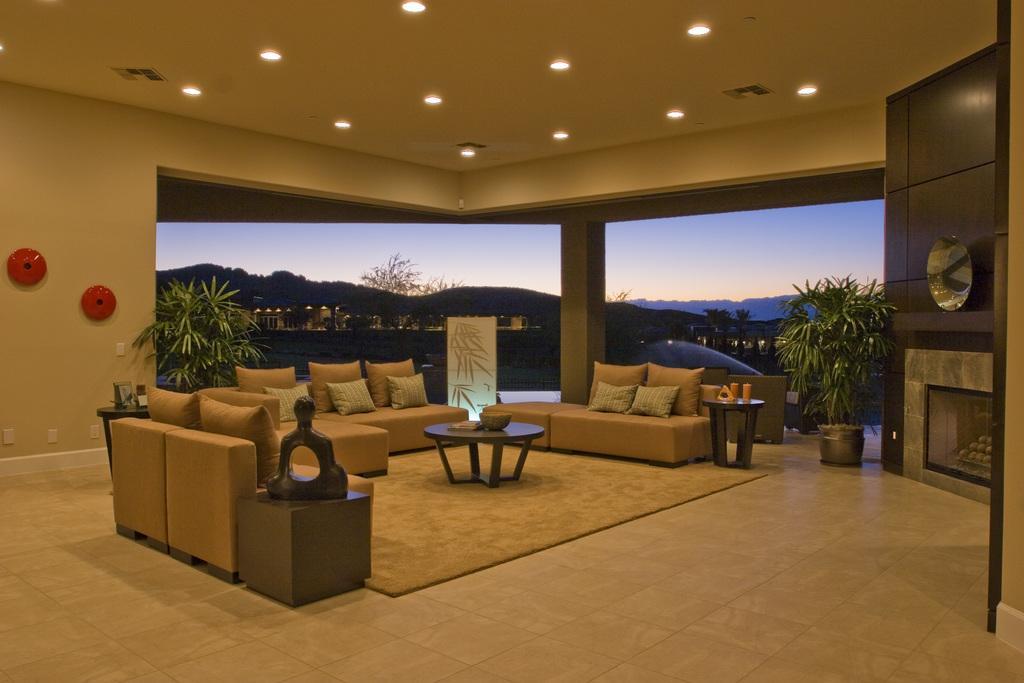Could you give a brief overview of what you see in this image? In a room there are sofas, pillows a floor mat. In the middle there is a table. On the table there are some object. And to the left corner of the wall there are some objects and a plant. In the background we can see some trees, hills. And to the right side there is a plant. 